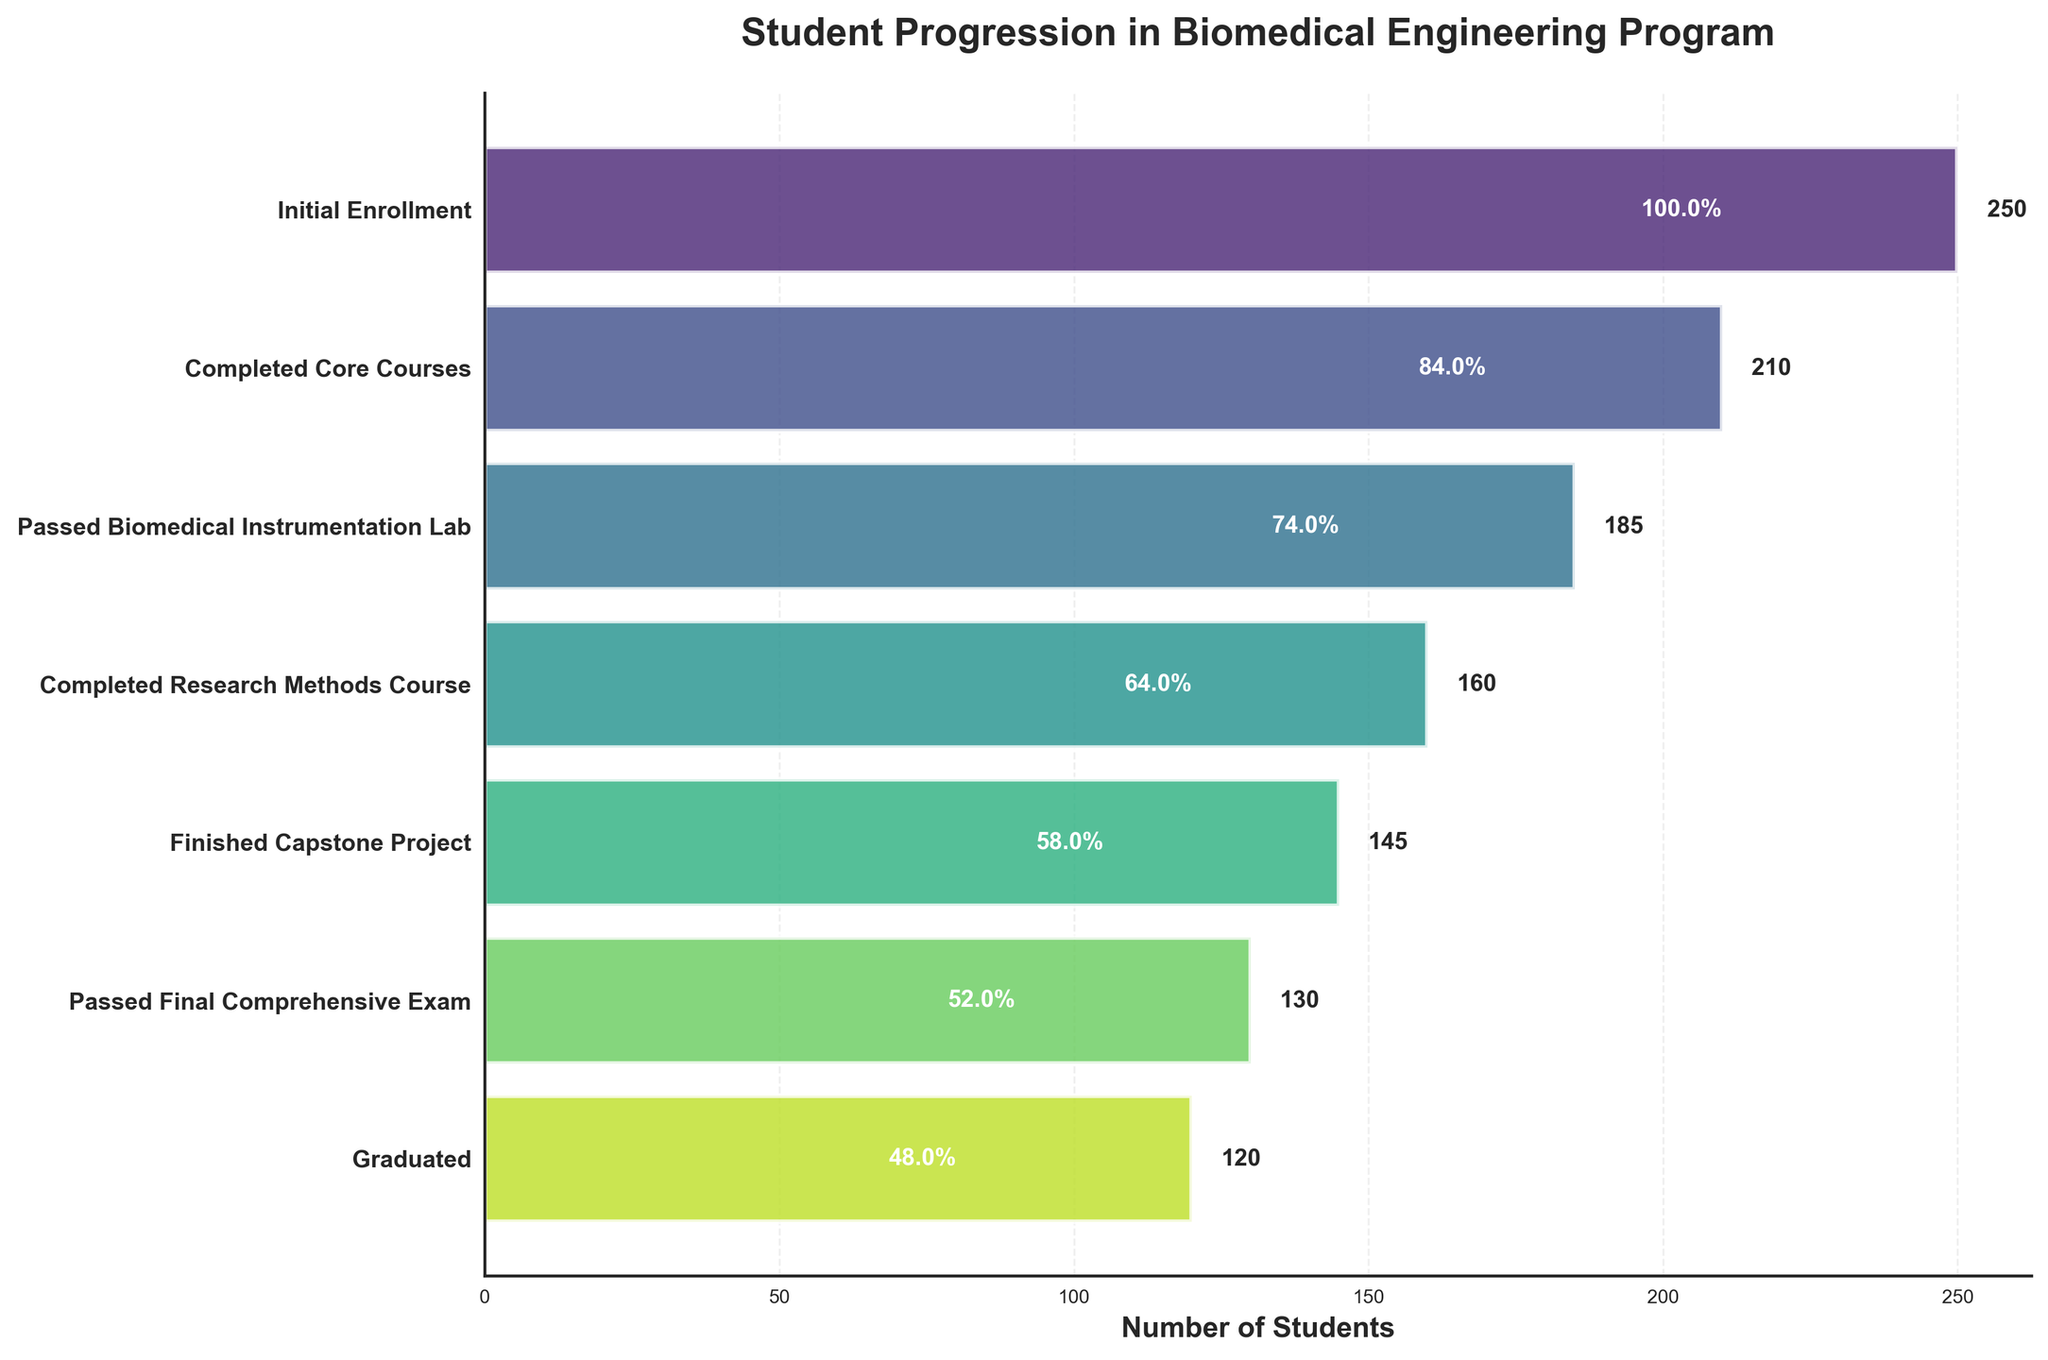How many students graduated from the biomedical engineering program? According to the last stage in the funnel chart labeled "Graduated," we can see that the number of students in this stage is given.
Answer: 120 What is the title of the figure? The title is usually located at the top of the chart. In this case, it is clearly written in bold above the funnel chart.
Answer: Student Progression in Biomedical Engineering Program Which stage has the largest drop in the number of students? To find the largest drop, we compare the differences in student counts between each consecutive stage. The largest numeric difference will indicate the largest drop in student count.
Answer: Initial Enrollment to Completed Core Courses What percentage of students who initially enrolled completed the capstone project? We need to divide the number of students who completed the capstone project by the initial enrollment number and then multiply by 100 to get the percentage. 145/250*100 = 58%
Answer: 58% Which stage showed a decrease in student numbers by 25 students? By examining the student numbers for each stage, we identify the two stages where the difference is exactly 25 students.
Answer: Completed Core Courses to Passed Biomedical Instrumentation Lab How many more students completed the core courses than finished the capstone project? We need to subtract the number of students who finished the capstone project from those who completed the core courses. 210 - 145
Answer: 65 Is the percentage of students who passed the final comprehensive exam higher than the percentage of those who finished the capstone project? Calculate each percentage relative to the initial enrollment. The percentage for the final comprehensive exam is 130/250*100 = 52%, and for the capstone project is 145/250*100 = 58%. Compare these percentages.
Answer: No What is the average number of students across all stages? Sum the number of students in each stage, then divide by the number of stages. (250+210+185+160+145+130+120)/7
Answer: 171.4 Which stage represents 65% of the initial enrollment? Calculate 65% of the initial enrollment (250 * 0.65 = 162.5) and identify the stage whose student count is closest to this value.
Answer: Completed Research Methods Course What proportion of students passed the biomedical instrumentation lab out of those who completed the core courses? Divide the number of students who passed the lab by the number who completed the core courses, then multiply by 100 to get the percentage. 185/210*100
Answer: 88.1% 